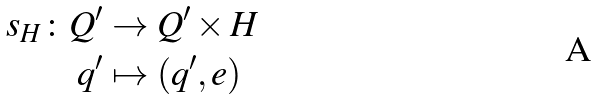Convert formula to latex. <formula><loc_0><loc_0><loc_500><loc_500>s _ { H } \colon Q ^ { \prime } & \to Q ^ { \prime } \times H \\ q ^ { \prime } & \mapsto ( q ^ { \prime } , e )</formula> 